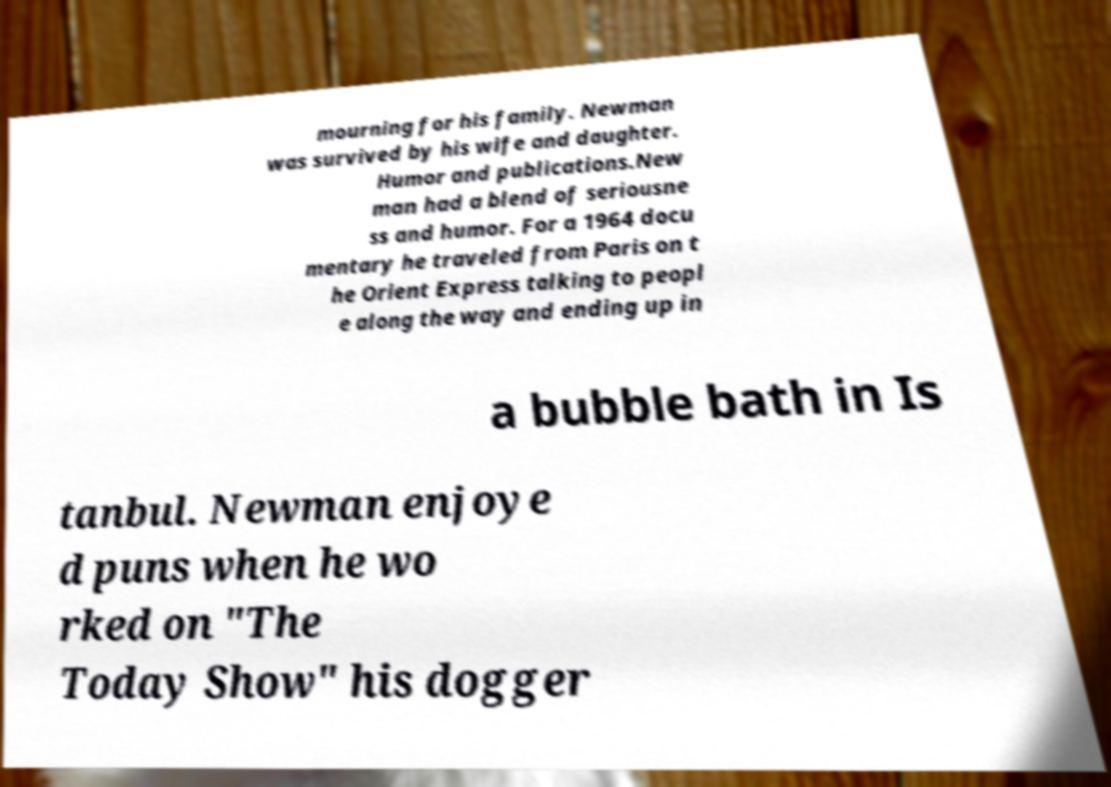Can you accurately transcribe the text from the provided image for me? mourning for his family. Newman was survived by his wife and daughter. Humor and publications.New man had a blend of seriousne ss and humor. For a 1964 docu mentary he traveled from Paris on t he Orient Express talking to peopl e along the way and ending up in a bubble bath in Is tanbul. Newman enjoye d puns when he wo rked on "The Today Show" his dogger 